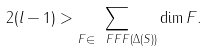Convert formula to latex. <formula><loc_0><loc_0><loc_500><loc_500>2 ( l - 1 ) > \sum _ { F \in \ F F F ( \Delta ( S ) ) } \dim F .</formula> 